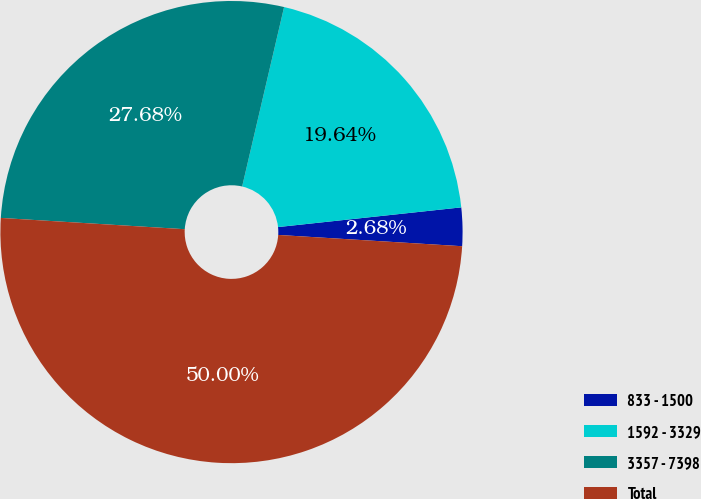<chart> <loc_0><loc_0><loc_500><loc_500><pie_chart><fcel>833 - 1500<fcel>1592 - 3329<fcel>3357 - 7398<fcel>Total<nl><fcel>2.68%<fcel>19.64%<fcel>27.68%<fcel>50.0%<nl></chart> 